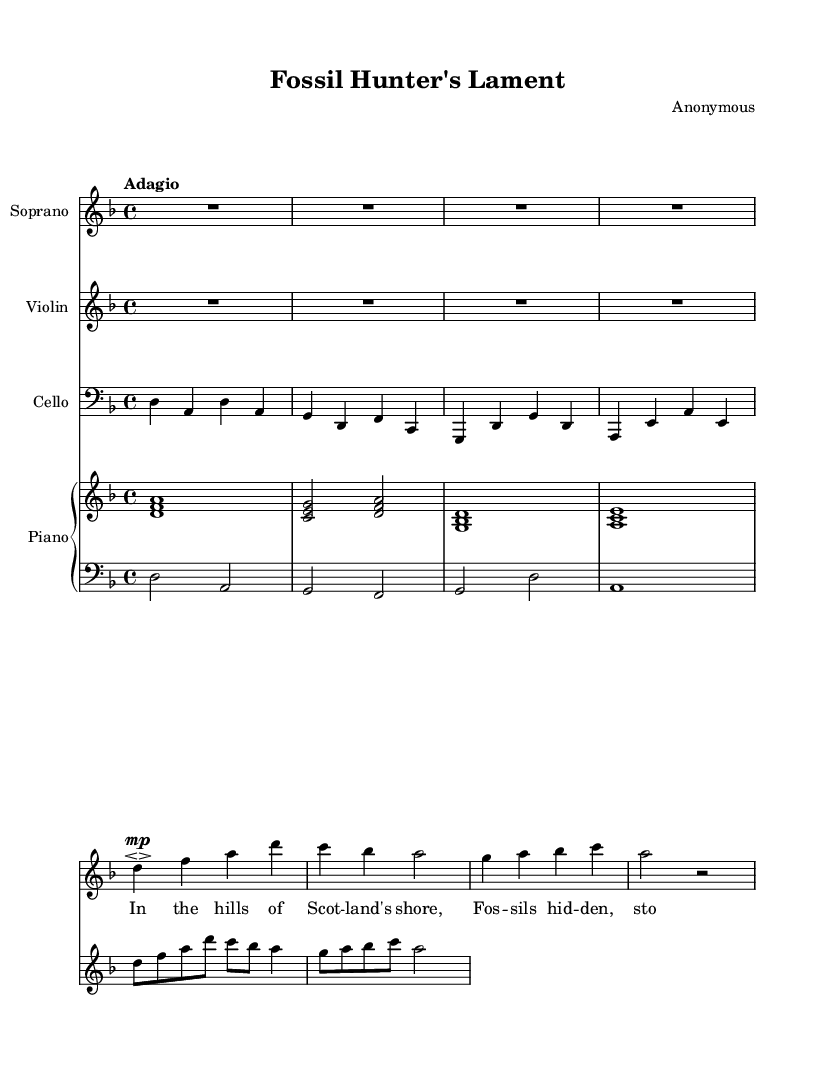What is the key signature of this music? The key signature is indicated by the symbols at the beginning of the staff. In this case, it shows a key signature with one flat, indicating the key of D minor.
Answer: D minor What is the time signature of this piece? The time signature is shown as a fraction at the beginning of the staff. Here, it is displayed as 4/4, meaning there are four beats in a measure and the quarter note gets one beat.
Answer: 4/4 What is the tempo marking for this work? The tempo marking is typically located directly above or below the first measure. In this sheet music, it is marked "Adagio," which suggests a slow and leisurely pace.
Answer: Adagio How many measures are in the soprano part? To determine the total number of measures, one has to count the vertical lines that separate the measures in the soprano part. There are a total of 6 measures present in the soprano part.
Answer: 6 Name one of the instruments featured in this sheet music. The instruments are listed at the beginning of each staff. For example, the first staff is for Soprano, and the second one is Violin.
Answer: Soprano What is the dynamic marking in the soprano voice? The dynamic marking is indicated in the soprano part with a symbol near the notes. It shows "mp" meaning moderately soft, guiding the performer on how to expressively sing those notes.
Answer: mp Identify the instrument playing the bass clef. The instrument is labeled at the beginning of the staff in the bass clef. Here, it clearly states "Cello" at the beginning of the staff.
Answer: Cello 